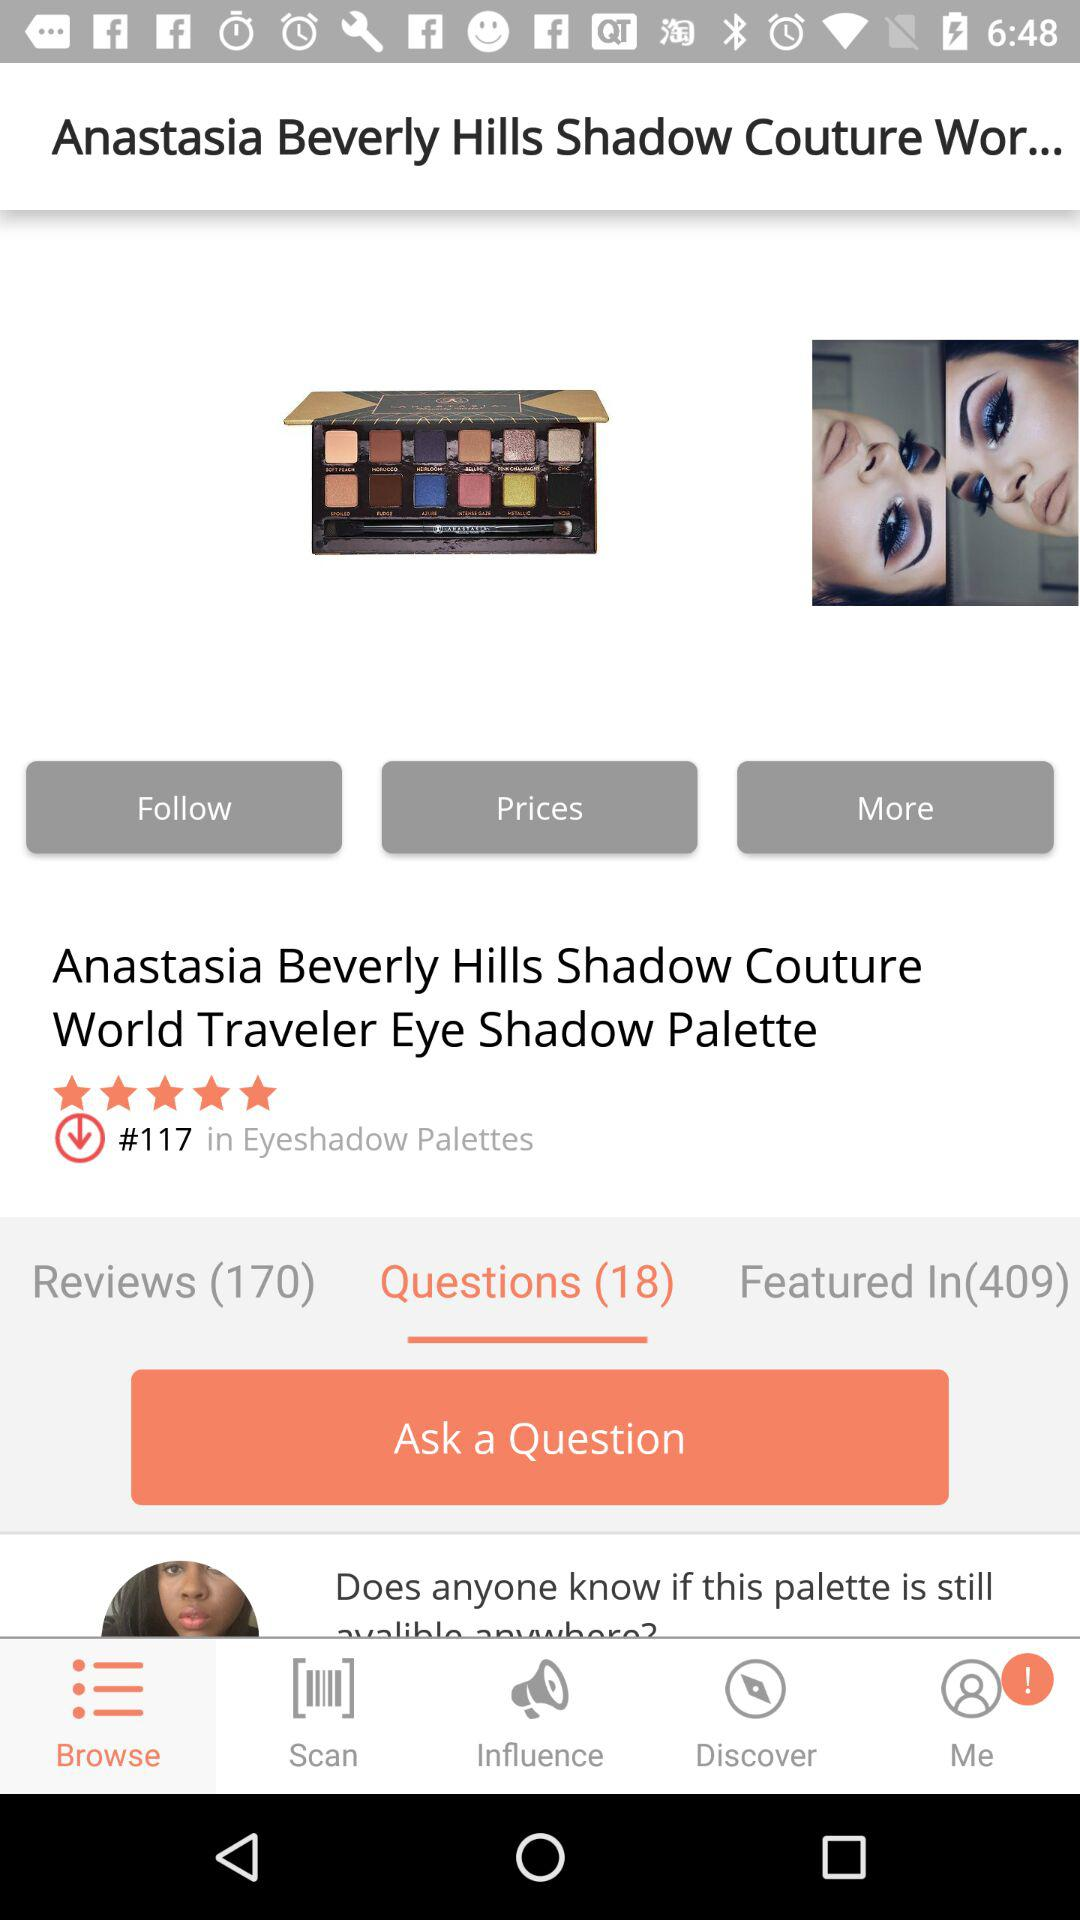How many reviews are there for this product?
Answer the question using a single word or phrase. 170 